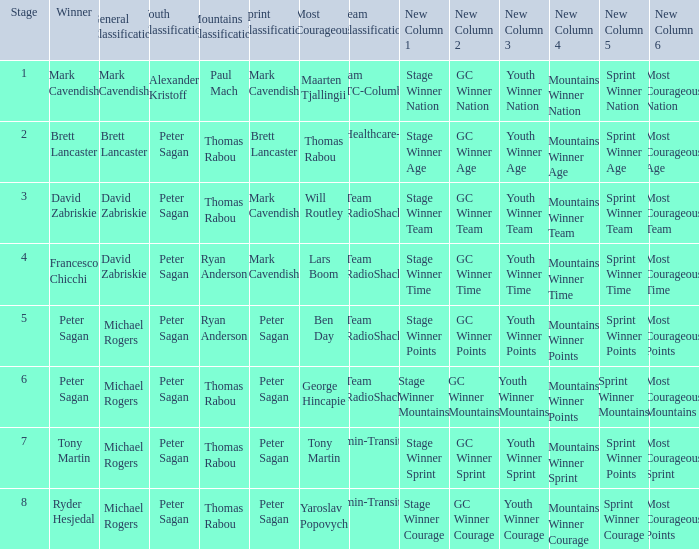When Peter Sagan won the youth classification and Thomas Rabou won the most corageous, who won the sprint classification? Brett Lancaster. 